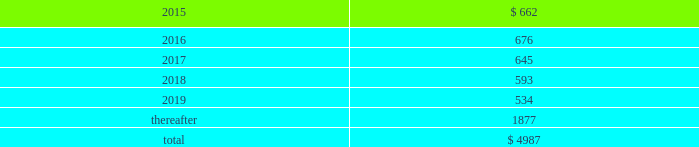Table of contents concentrations in the available sources of supply of materials and product although most components essential to the company 2019s business are generally available from multiple sources , a number of components are currently obtained from single or limited sources .
In addition , the company competes for various components with other participants in the markets for mobile communication and media devices and personal computers .
Therefore , many components used by the company , including those that are available from multiple sources , are at times subject to industry-wide shortage and significant pricing fluctuations that could materially adversely affect the company 2019s financial condition and operating results .
The company uses some custom components that are not commonly used by its competitors , and new products introduced by the company often utilize custom components available from only one source .
When a component or product uses new technologies , initial capacity constraints may exist until the suppliers 2019 yields have matured or manufacturing capacity has increased .
If the company 2019s supply of components for a new or existing product were delayed or constrained , or if an outsourcing partner delayed shipments of completed products to the company , the company 2019s financial condition and operating results could be materially adversely affected .
The company 2019s business and financial performance could also be materially adversely affected depending on the time required to obtain sufficient quantities from the original source , or to identify and obtain sufficient quantities from an alternative source .
Continued availability of these components at acceptable prices , or at all , may be affected if those suppliers concentrated on the production of common components instead of components customized to meet the company 2019s requirements .
The company has entered into agreements for the supply of many components ; however , there can be no guarantee that the company will be able to extend or renew these agreements on similar terms , or at all .
Therefore , the company remains subject to significant risks of supply shortages and price increases that could materially adversely affect its financial condition and operating results .
Substantially all of the company 2019s hardware products are manufactured by outsourcing partners that are located primarily in asia .
A significant concentration of this manufacturing is currently performed by a small number of outsourcing partners , often in single locations .
Certain of these outsourcing partners are the sole-sourced suppliers of components and manufacturers for many of the company 2019s products .
Although the company works closely with its outsourcing partners on manufacturing schedules , the company 2019s operating results could be adversely affected if its outsourcing partners were unable to meet their production commitments .
The company 2019s purchase commitments typically cover its requirements for periods up to 150 days .
Other off-balance sheet commitments operating leases the company leases various equipment and facilities , including retail space , under noncancelable operating lease arrangements .
The company does not currently utilize any other off-balance sheet financing arrangements .
The major facility leases are typically for terms not exceeding 10 years and generally contain multi-year renewal options .
Leases for retail space are for terms ranging from five to 20 years , the majority of which are for 10 years , and often contain multi-year renewal options .
As of september 27 , 2014 , the company 2019s total future minimum lease payments under noncancelable operating leases were $ 5.0 billion , of which $ 3.6 billion related to leases for retail space .
Rent expense under all operating leases , including both cancelable and noncancelable leases , was $ 717 million , $ 645 million and $ 488 million in 2014 , 2013 and 2012 , respectively .
Future minimum lease payments under noncancelable operating leases having remaining terms in excess of one year as of september 27 , 2014 , are as follows ( in millions ) : apple inc .
| 2014 form 10-k | 75 .

What was the change in rent expense under all operating leases , including both cancelable and noncancelable leases between 2014 and 2012 , in millions? 
Computations: (717 - 488)
Answer: 229.0. 